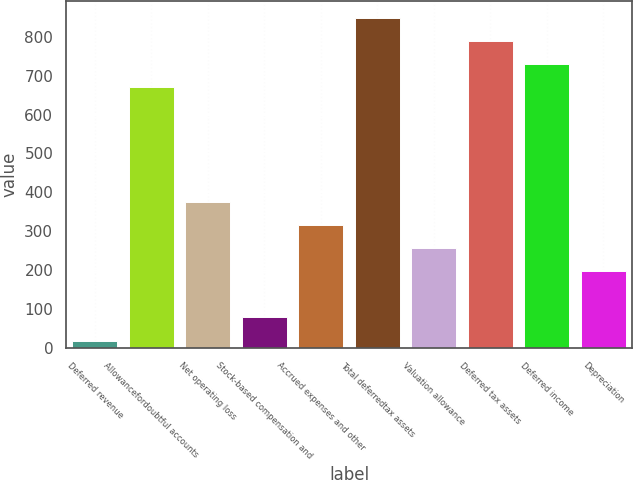Convert chart. <chart><loc_0><loc_0><loc_500><loc_500><bar_chart><fcel>Deferred revenue<fcel>Allowancefordoubtful accounts<fcel>Net operating loss<fcel>Stock-based compensation and<fcel>Accrued expenses and other<fcel>Total deferredtax assets<fcel>Valuation allowance<fcel>Deferred tax assets<fcel>Deferred income<fcel>Depreciation<nl><fcel>18.5<fcel>671.68<fcel>374.78<fcel>77.88<fcel>315.4<fcel>849.82<fcel>256.02<fcel>790.44<fcel>731.06<fcel>196.64<nl></chart> 